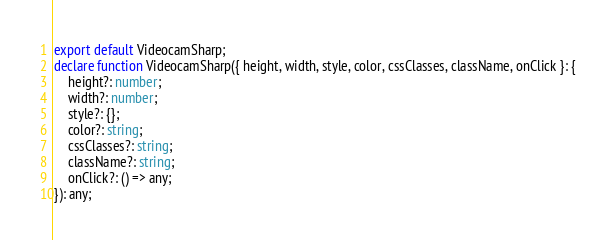<code> <loc_0><loc_0><loc_500><loc_500><_TypeScript_>export default VideocamSharp;
declare function VideocamSharp({ height, width, style, color, cssClasses, className, onClick }: {
    height?: number;
    width?: number;
    style?: {};
    color?: string;
    cssClasses?: string;
    className?: string;
    onClick?: () => any;
}): any;
</code> 